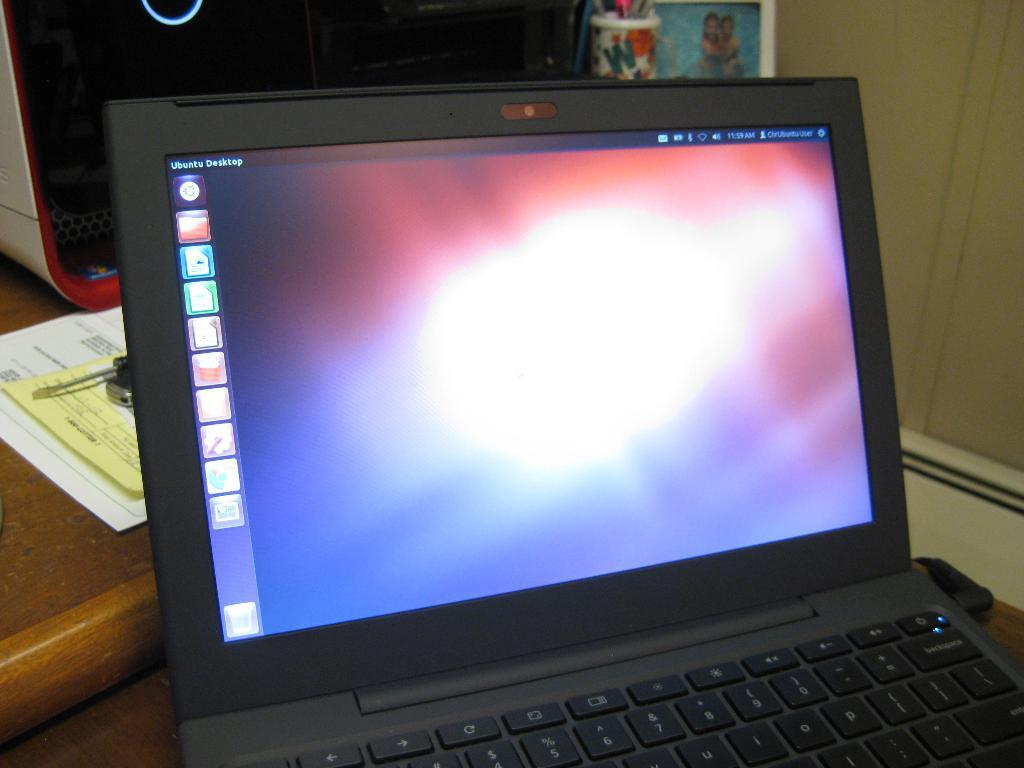Provide a one-sentence caption for the provided image. A computer on a table on with turned on with UBUntu Desktop in the left corner. 